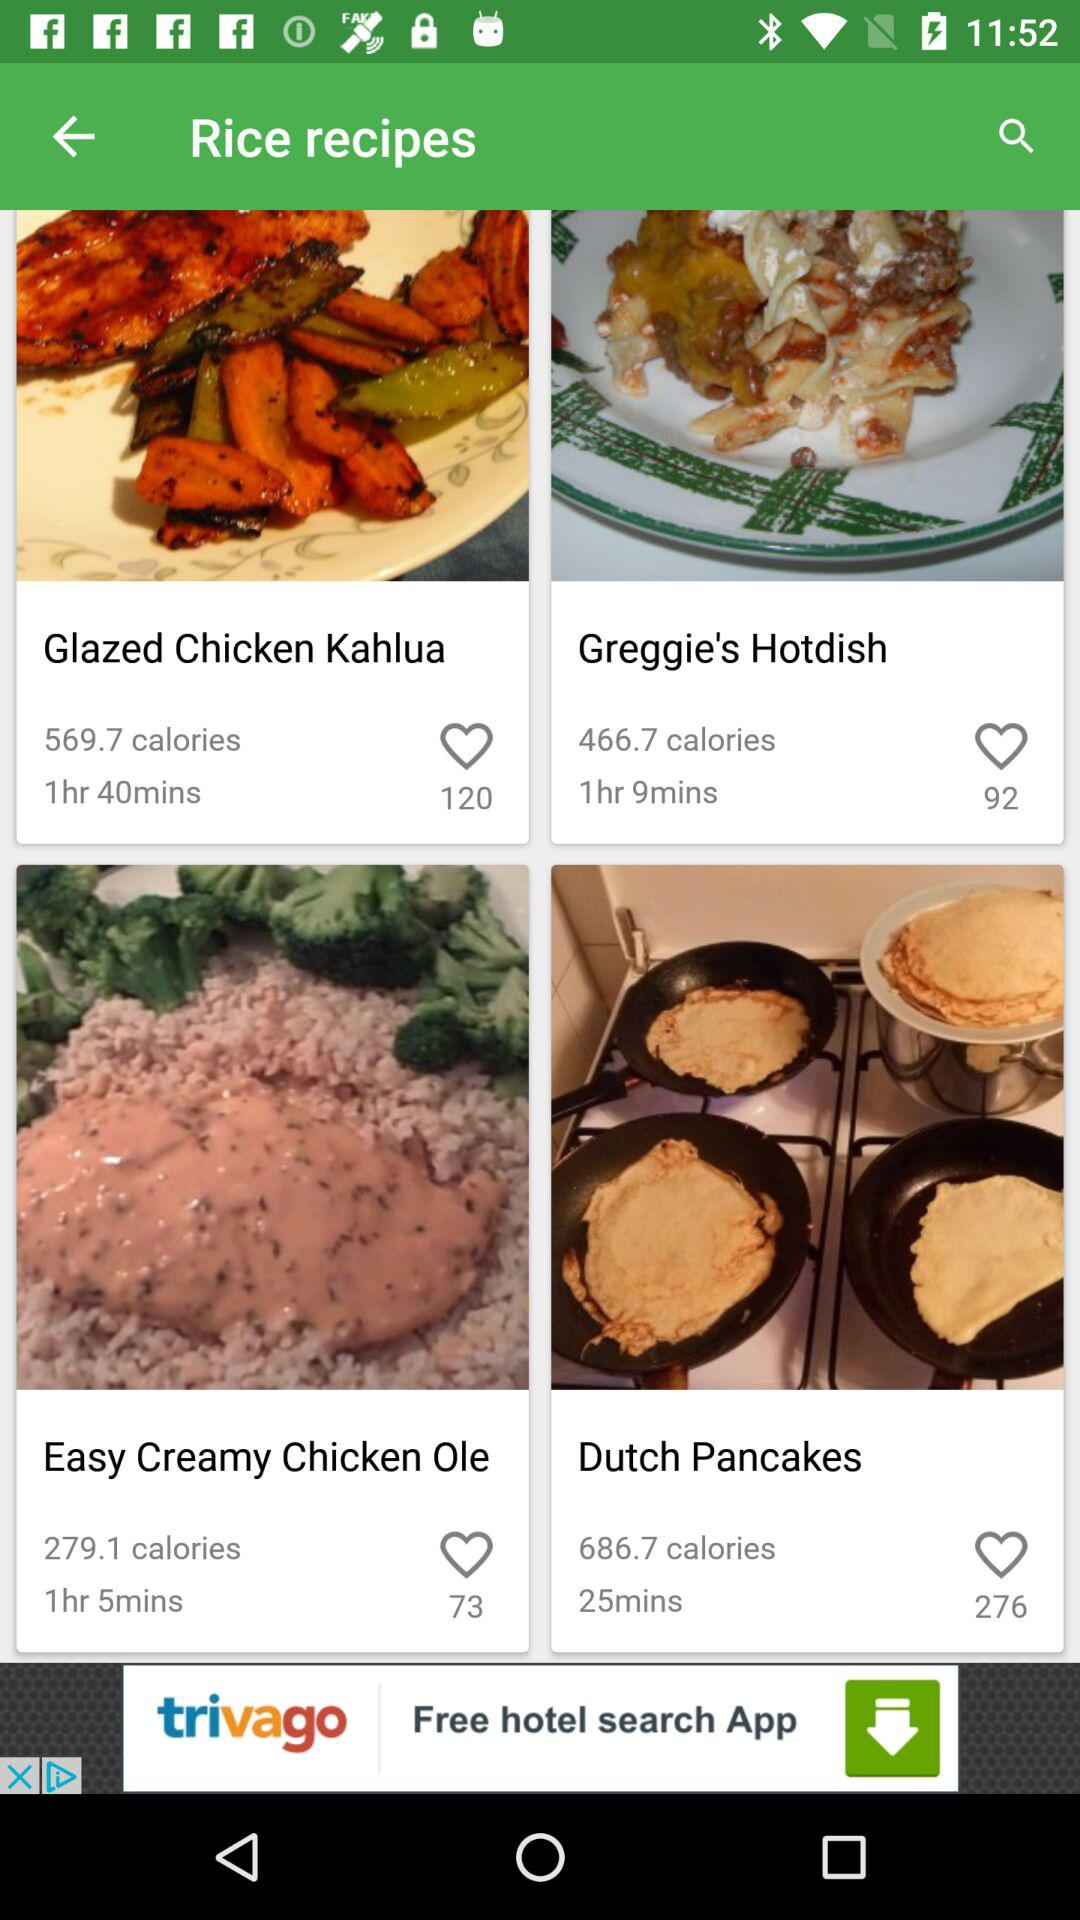What is the amount of calories in "Greggie's Hotdish"? The amount of calories is 466.7. 